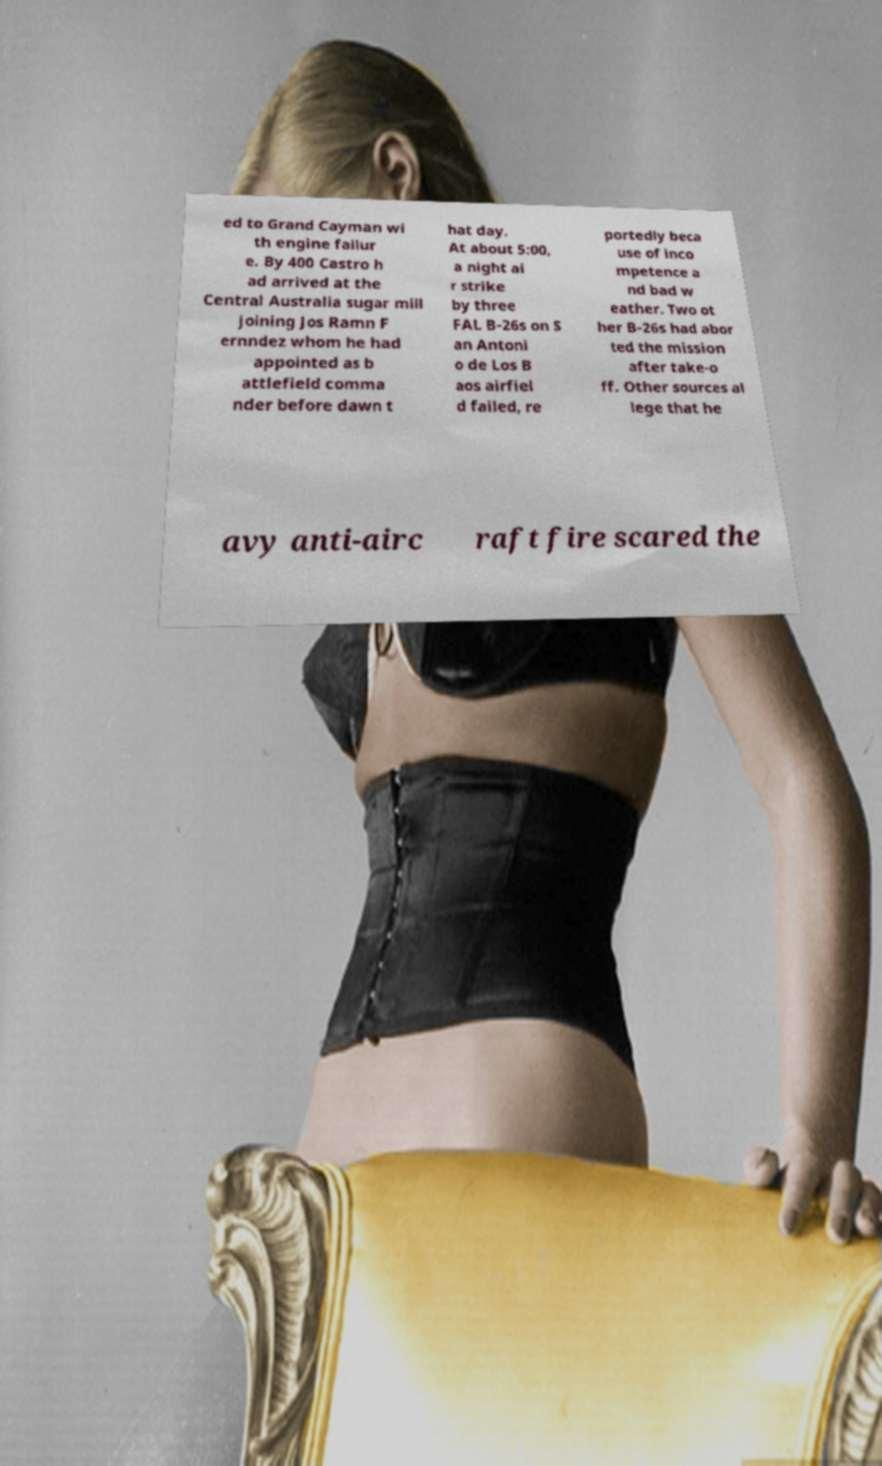Could you extract and type out the text from this image? ed to Grand Cayman wi th engine failur e. By 400 Castro h ad arrived at the Central Australia sugar mill joining Jos Ramn F ernndez whom he had appointed as b attlefield comma nder before dawn t hat day. At about 5:00, a night ai r strike by three FAL B-26s on S an Antoni o de Los B aos airfiel d failed, re portedly beca use of inco mpetence a nd bad w eather. Two ot her B-26s had abor ted the mission after take-o ff. Other sources al lege that he avy anti-airc raft fire scared the 